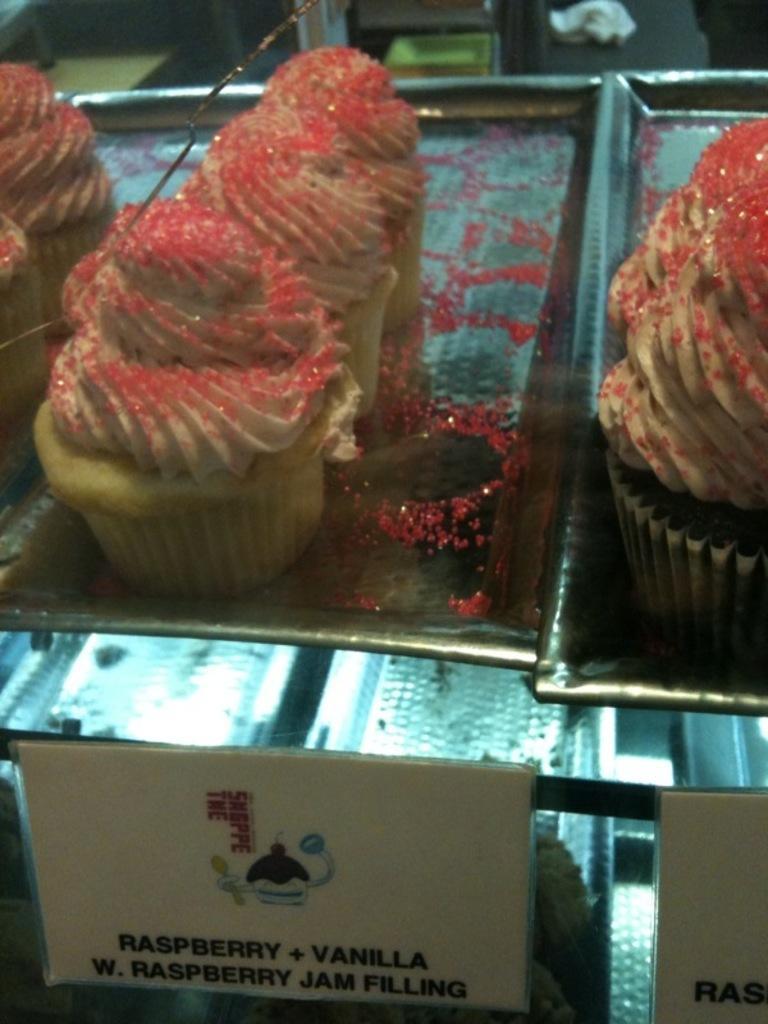How would you summarize this image in a sentence or two? In this picture I can observe some cupcakes placed in the tray. These cakes are in pink and cream colors. On the bottom of the picture I can observe name boards. There is some text on the boards. 